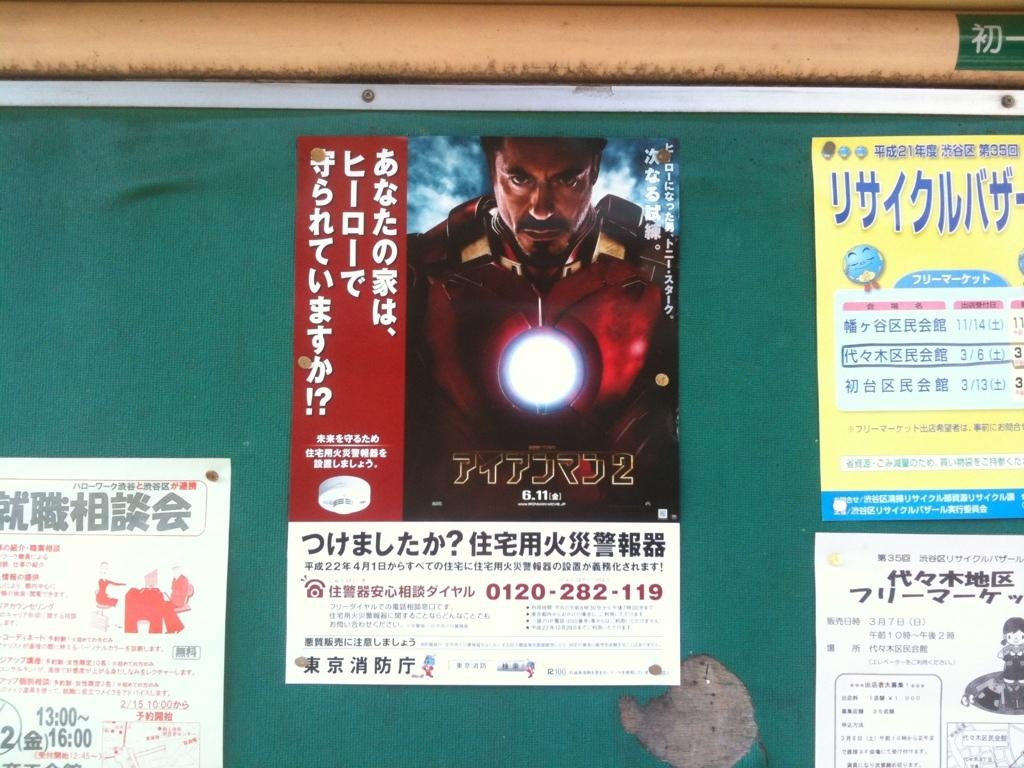What is the main object in the image? There is a board in the image. What is on the board? There are posters on thes on the board. What information can be found on the posters? The posters contain text and images. How many sisters are depicted on the posters? There are no sisters depicted on the posters; the posters contain text and images related to other subjects. 